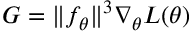<formula> <loc_0><loc_0><loc_500><loc_500>G = \| f _ { \theta } \| ^ { 3 } \nabla _ { \theta } L ( \theta )</formula> 